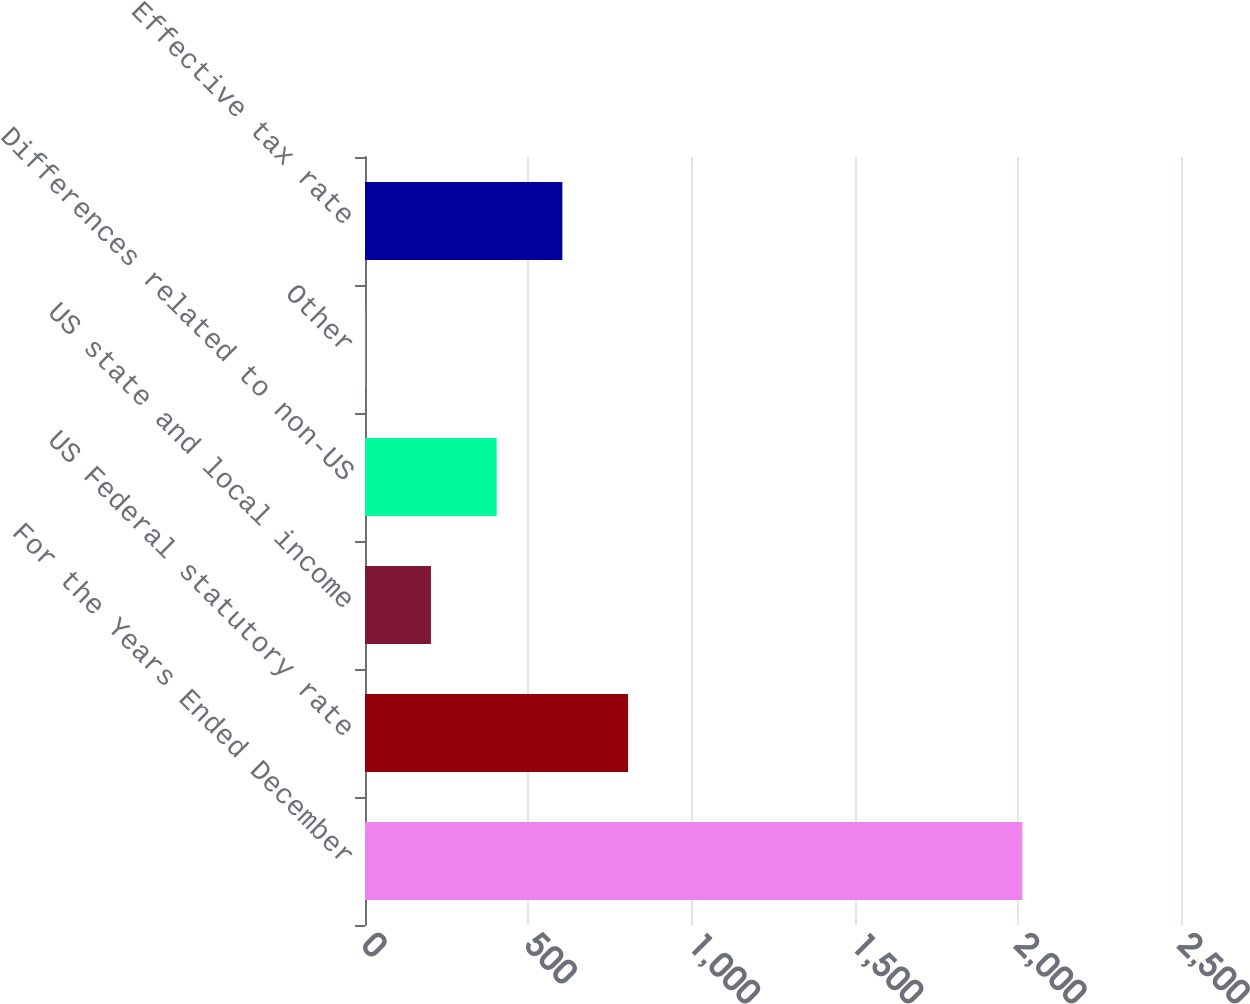<chart> <loc_0><loc_0><loc_500><loc_500><bar_chart><fcel>For the Years Ended December<fcel>US Federal statutory rate<fcel>US state and local income<fcel>Differences related to non-US<fcel>Other<fcel>Effective tax rate<nl><fcel>2014<fcel>806.02<fcel>202.03<fcel>403.36<fcel>0.7<fcel>604.69<nl></chart> 